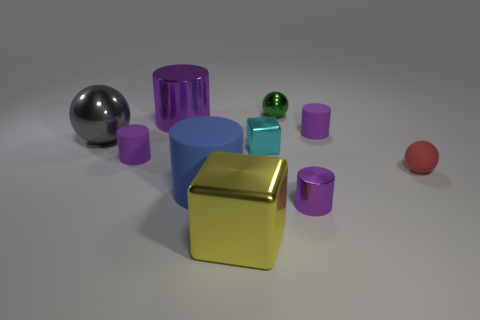Which object stands out the most and why? The gold cube stands out primarily due to its reflective metallic surface that catches the light, making it the visual center of interest among the otherwise matte objects. Its positioning and color contrast with the surrounding elements also contribute to its prominence.  What might be the purpose of creating this image? The image could serve multiple purposes: it could be a rendering to illustrate material and light interactions in a 3D modeling software, an art piece to evoke contemplation on form and color, or an educational tool to discuss geometry and physics of light reflection and shadow casting. 